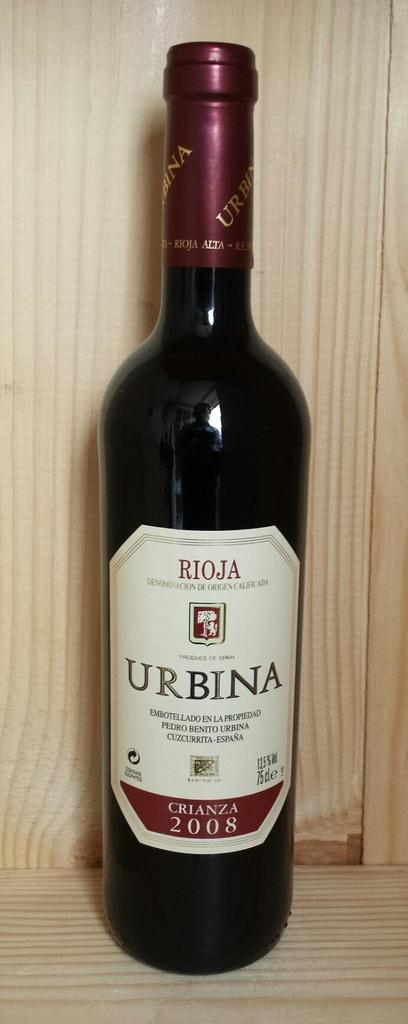<image>
Offer a succinct explanation of the picture presented. A bottle of Urbina wine from 2008 sits on a wooden shelf. 